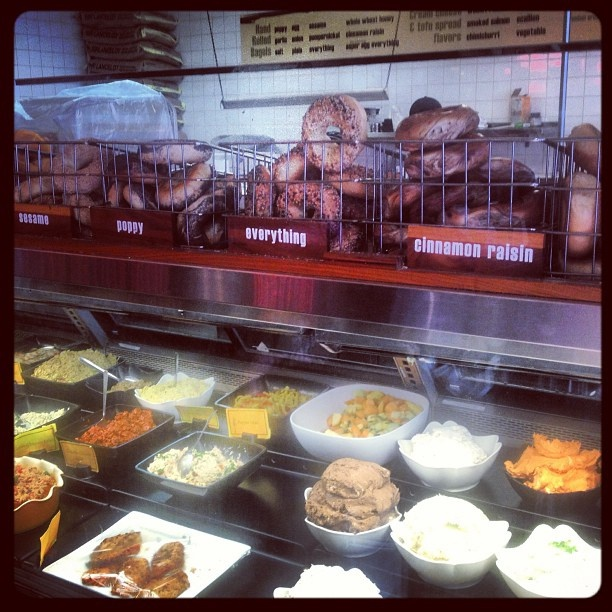Describe the objects in this image and their specific colors. I can see bowl in black, lightgray, darkgray, and tan tones, bowl in black, ivory, darkgray, gray, and beige tones, bowl in black, white, darkgray, gray, and khaki tones, bowl in black, darkgray, beige, and gray tones, and bowl in black, tan, and darkgray tones in this image. 